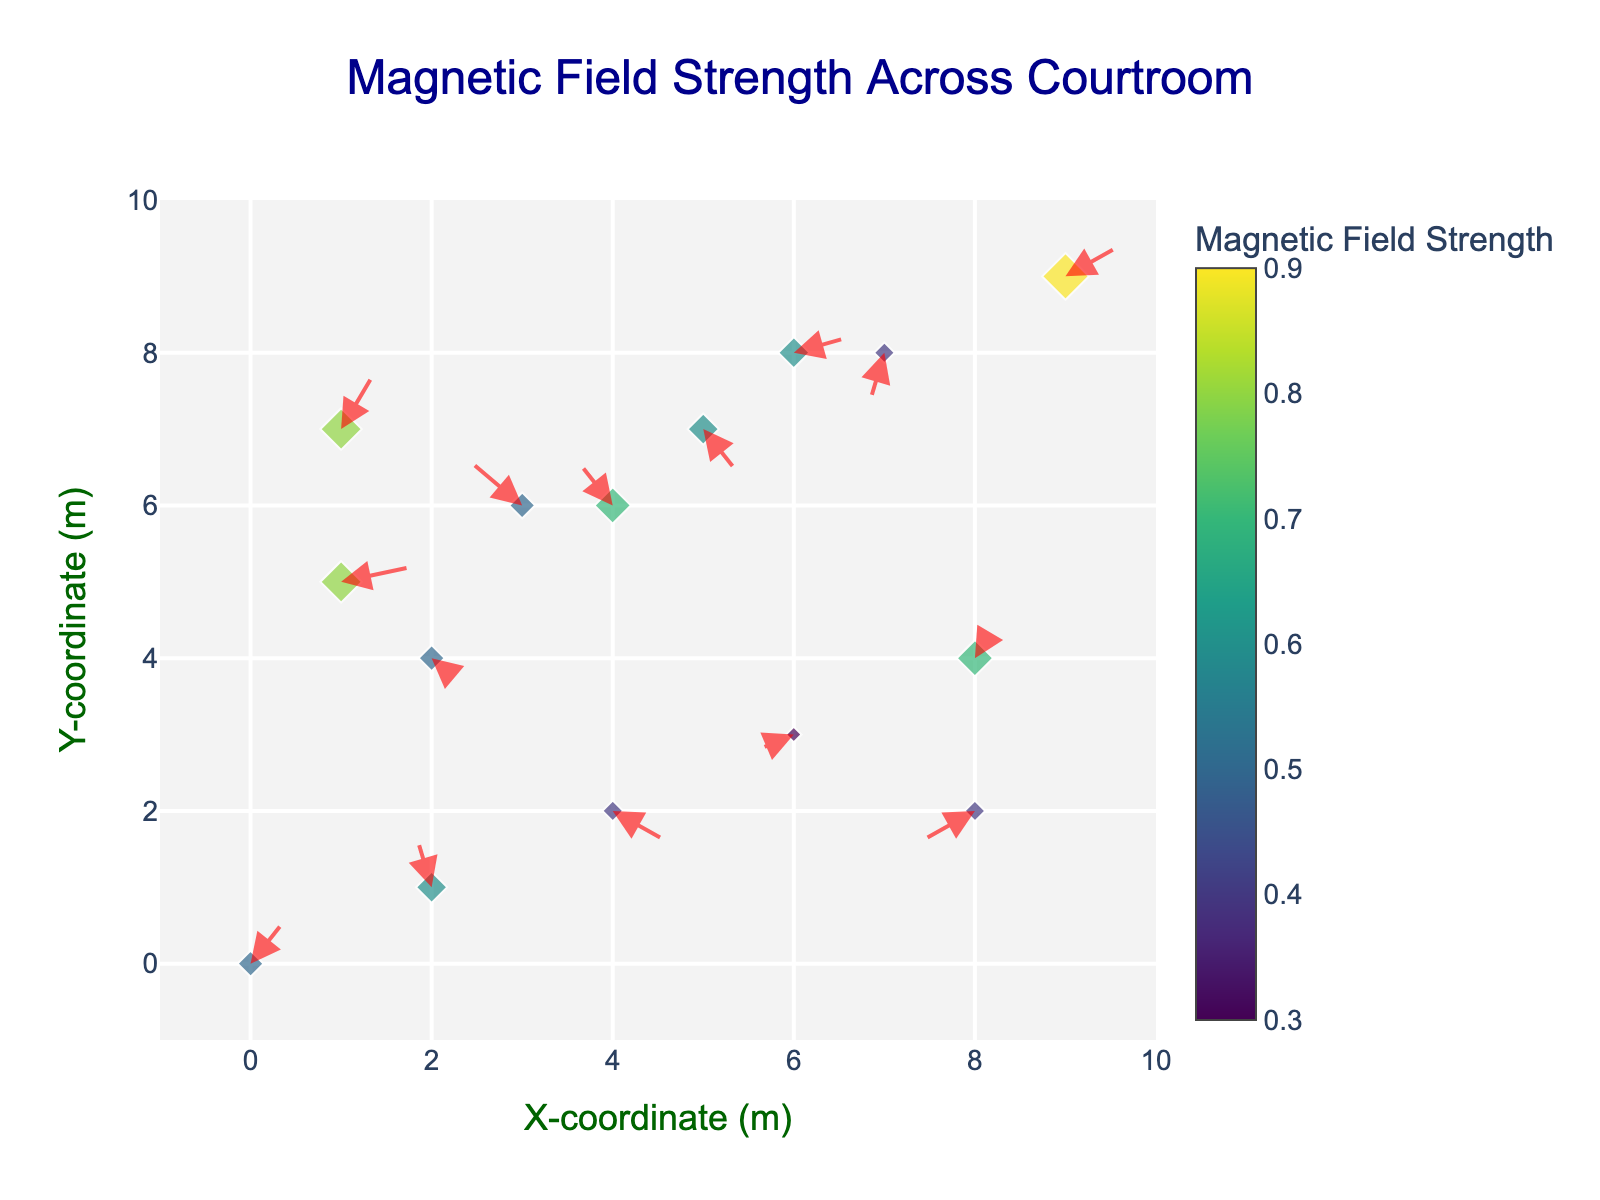What is the title of the figure? The title of the figure is displayed prominently at the top of the chart, reading "Magnetic Field Strength Across Courtroom".
Answer: Magnetic Field Strength Across Courtroom How many points are displayed on the plot? Each point represents a set of (x, y) coordinates, and there are markers corresponding to the number of rows in the data. Counting all the markers, there are 15 points.
Answer: 15 What does the color of the markers represent? The color of the markers corresponds to the magnitude of the magnetic field strength at each point, as indicated by the color bar labeled "Magnetic Field Strength".
Answer: Magnetic field strength Which point has the largest marker size? Marker size is proportional to the magnetic field strength, so the point with the highest strength value, 0.9, will have the largest marker size. This point is at coordinates (9, 9).
Answer: (9, 9) Which direction do most arrows point in the area with high magnetic field strength? To determine this, observe the arrows near points with higher strength values (closer to 1). For example, in regions around points (1, 5), (1, 7), (9, 9), most arrows point upwards or have components primarily in the positive Y direction.
Answer: Upwards What are the coordinates of the point where the arrow is pointing straight down? Arrows pointing straight down will have a v component close to -0.4 and a u component close to 0. One such point is at coordinates (7, 8), where the arrow points straight down with a (u, v) vector of (-0.1, -0.4).
Answer: (7, 8) What is the average magnetic field strength across all points? Sum the magnetic field strength of all points (0.5+0.6+0.4+0.3+0.7+0.8+0.5+0.6+0.4+0.9+0.5+0.7+0.6+0.4+0.8) and divide by the number of points (15). The calculation is (0.5+0.6+0.4+0.3+0.7+0.8+0.5+0.6+0.4+0.9+0.5+0.7+0.6+0.4+0.8) / 15 = 8.7 / 15 = 0.58.
Answer: 0.58 Which point has an arrow with the largest length and what is its magnetic field strength? Arrow length can be computed as sqrt(u^2 + v^2). The longest arrow will have the largest value of sqrt(u^2 + v^2). Here, check each coordinate's arrows: for example, at (2, 1) with u = -0.1 and v = 0.4, the length is sqrt((-0.1)^2 + 0.4^2) = sqrt(0.01 + 0.16) = sqrt(0.17) ≈ 0.41. Comparing all lengths, the longest arrow exists at point (1, 7) with sqrt(0.2^2 + 0.4^2) = sqrt(0.2) ≈ 0.63. Its magnetic field strength is 0.8.
Answer: (1, 7), 0.8 